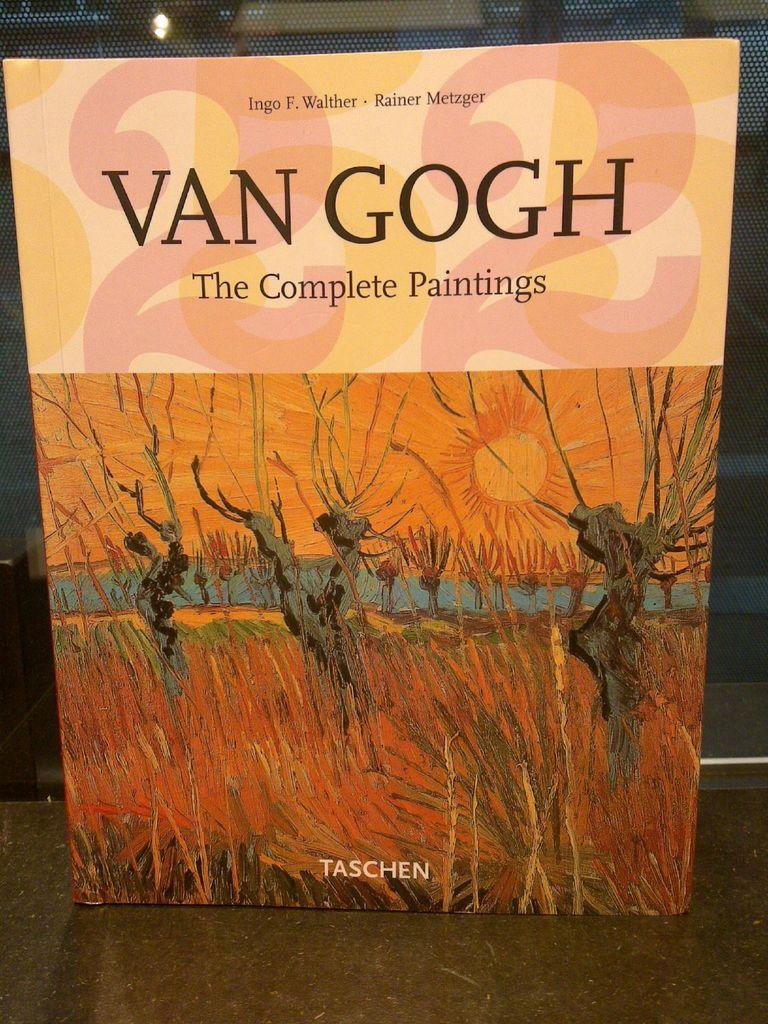What is the main object in the image? There is a board in the image. Where is the board located? The board is on a surface. What can be seen behind the board? There is a mesh visible behind the board. What type of nose does the board have in the image? The board does not have a nose, as it is an inanimate object. 